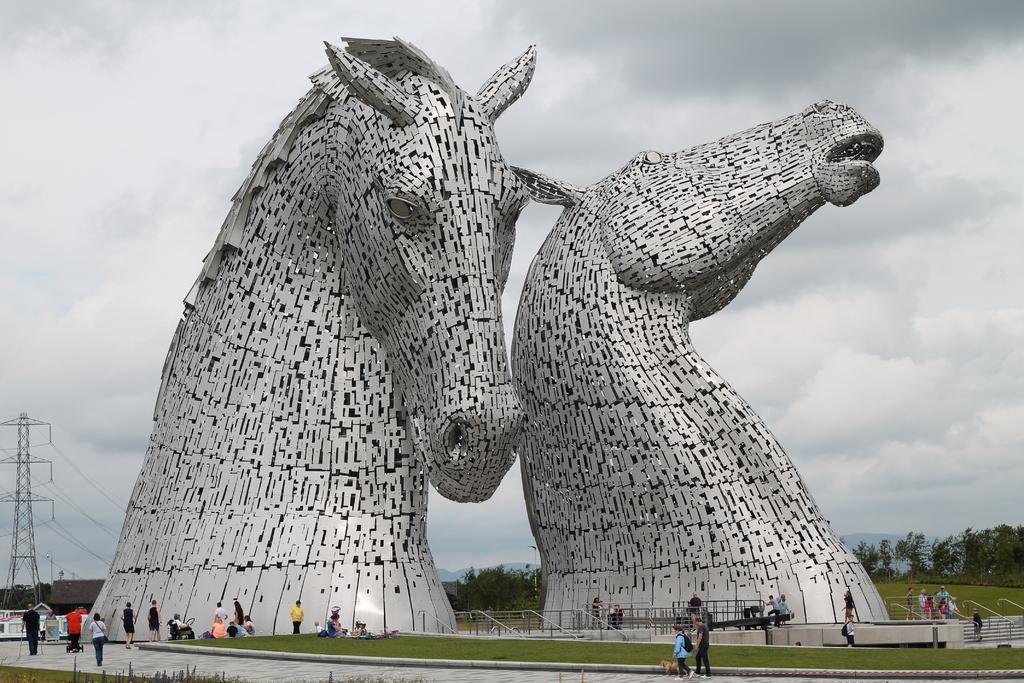Describe this image in one or two sentences. In this picture we can see horse sculptures, around we can see few people are walking and we can see some trees, grass. 